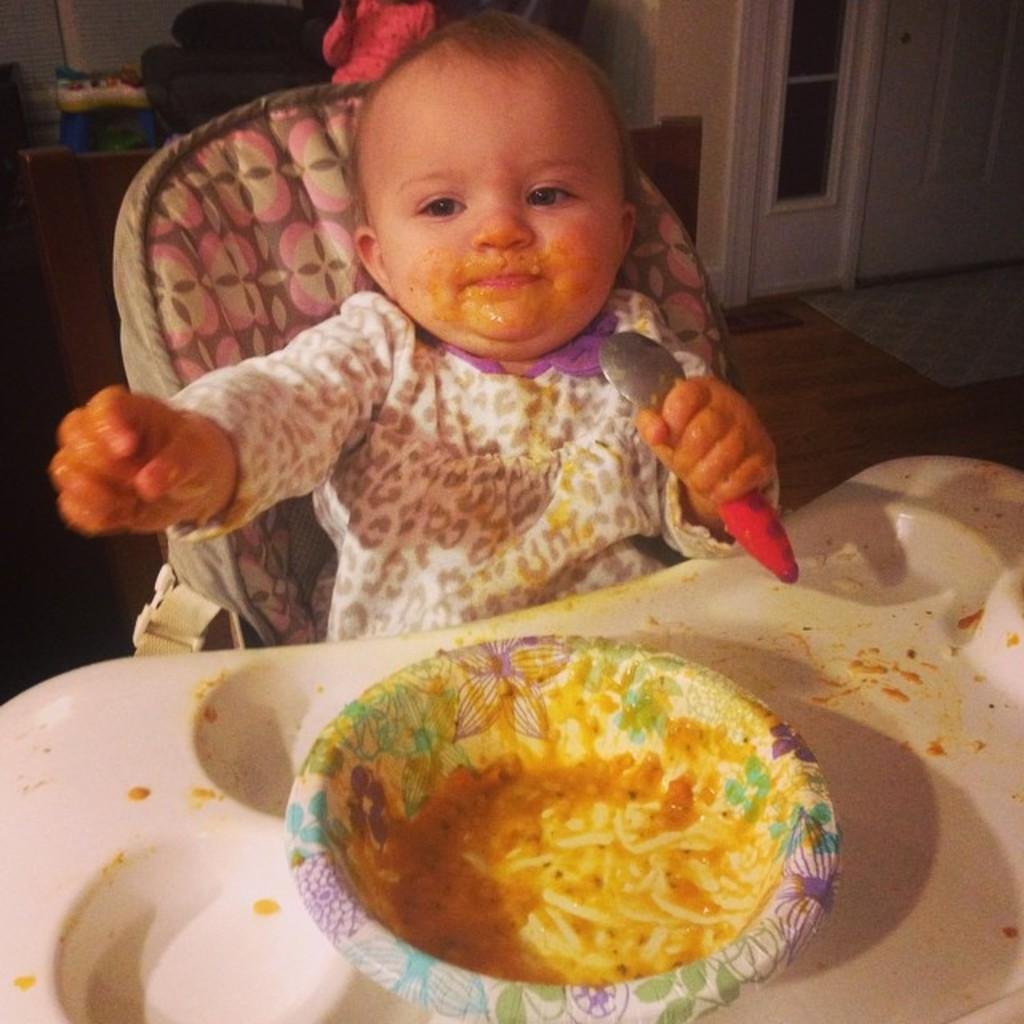What is in the bowl that is visible in the image? There is a bowl in the image, but the contents are not specified. Who is present in the image? There is a child in the image. What is the child doing in the image? The child is sitting and holding a spoon with their hand. What can be seen in the background of the image? There is a door and objects visible in the background of the image. What type of expansion is the child experiencing in the image? There is no indication of any expansion occurring in the image. Is the child holding a rifle in the image? No, the child is holding a spoon, not a rifle, in the image. 